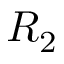<formula> <loc_0><loc_0><loc_500><loc_500>R _ { 2 }</formula> 